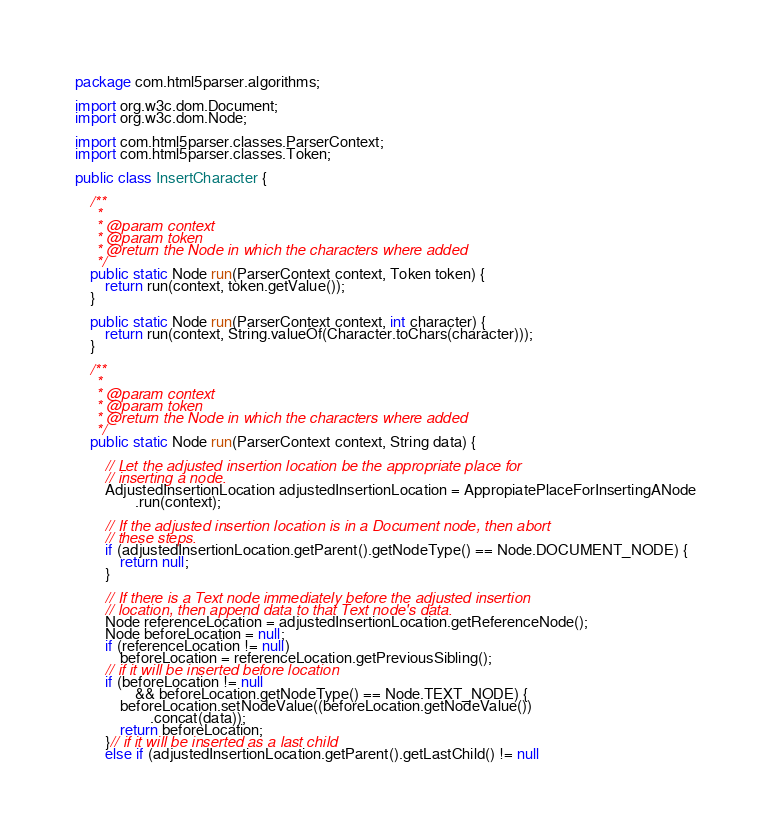Convert code to text. <code><loc_0><loc_0><loc_500><loc_500><_Java_>package com.html5parser.algorithms;

import org.w3c.dom.Document;
import org.w3c.dom.Node;

import com.html5parser.classes.ParserContext;
import com.html5parser.classes.Token;

public class InsertCharacter {

	/**
	 * 
	 * @param context
	 * @param token
	 * @return the Node in which the characters where added
	 */
	public static Node run(ParserContext context, Token token) {
		return run(context, token.getValue());
	}

	public static Node run(ParserContext context, int character) {
		return run(context, String.valueOf(Character.toChars(character)));
	}

	/**
	 * 
	 * @param context
	 * @param token
	 * @return the Node in which the characters where added
	 */
	public static Node run(ParserContext context, String data) {

		// Let the adjusted insertion location be the appropriate place for
		// inserting a node.
		AdjustedInsertionLocation adjustedInsertionLocation = AppropiatePlaceForInsertingANode
				.run(context);

		// If the adjusted insertion location is in a Document node, then abort
		// these steps.
		if (adjustedInsertionLocation.getParent().getNodeType() == Node.DOCUMENT_NODE) {
			return null;
		}

		// If there is a Text node immediately before the adjusted insertion
		// location, then append data to that Text node's data.
		Node referenceLocation = adjustedInsertionLocation.getReferenceNode();
		Node beforeLocation = null;
		if (referenceLocation != null)
			beforeLocation = referenceLocation.getPreviousSibling();
		// if it will be inserted before location
		if (beforeLocation != null
				&& beforeLocation.getNodeType() == Node.TEXT_NODE) {
			beforeLocation.setNodeValue((beforeLocation.getNodeValue())
					.concat(data));
			return beforeLocation;
		}// if it will be inserted as a last child
		else if (adjustedInsertionLocation.getParent().getLastChild() != null</code> 